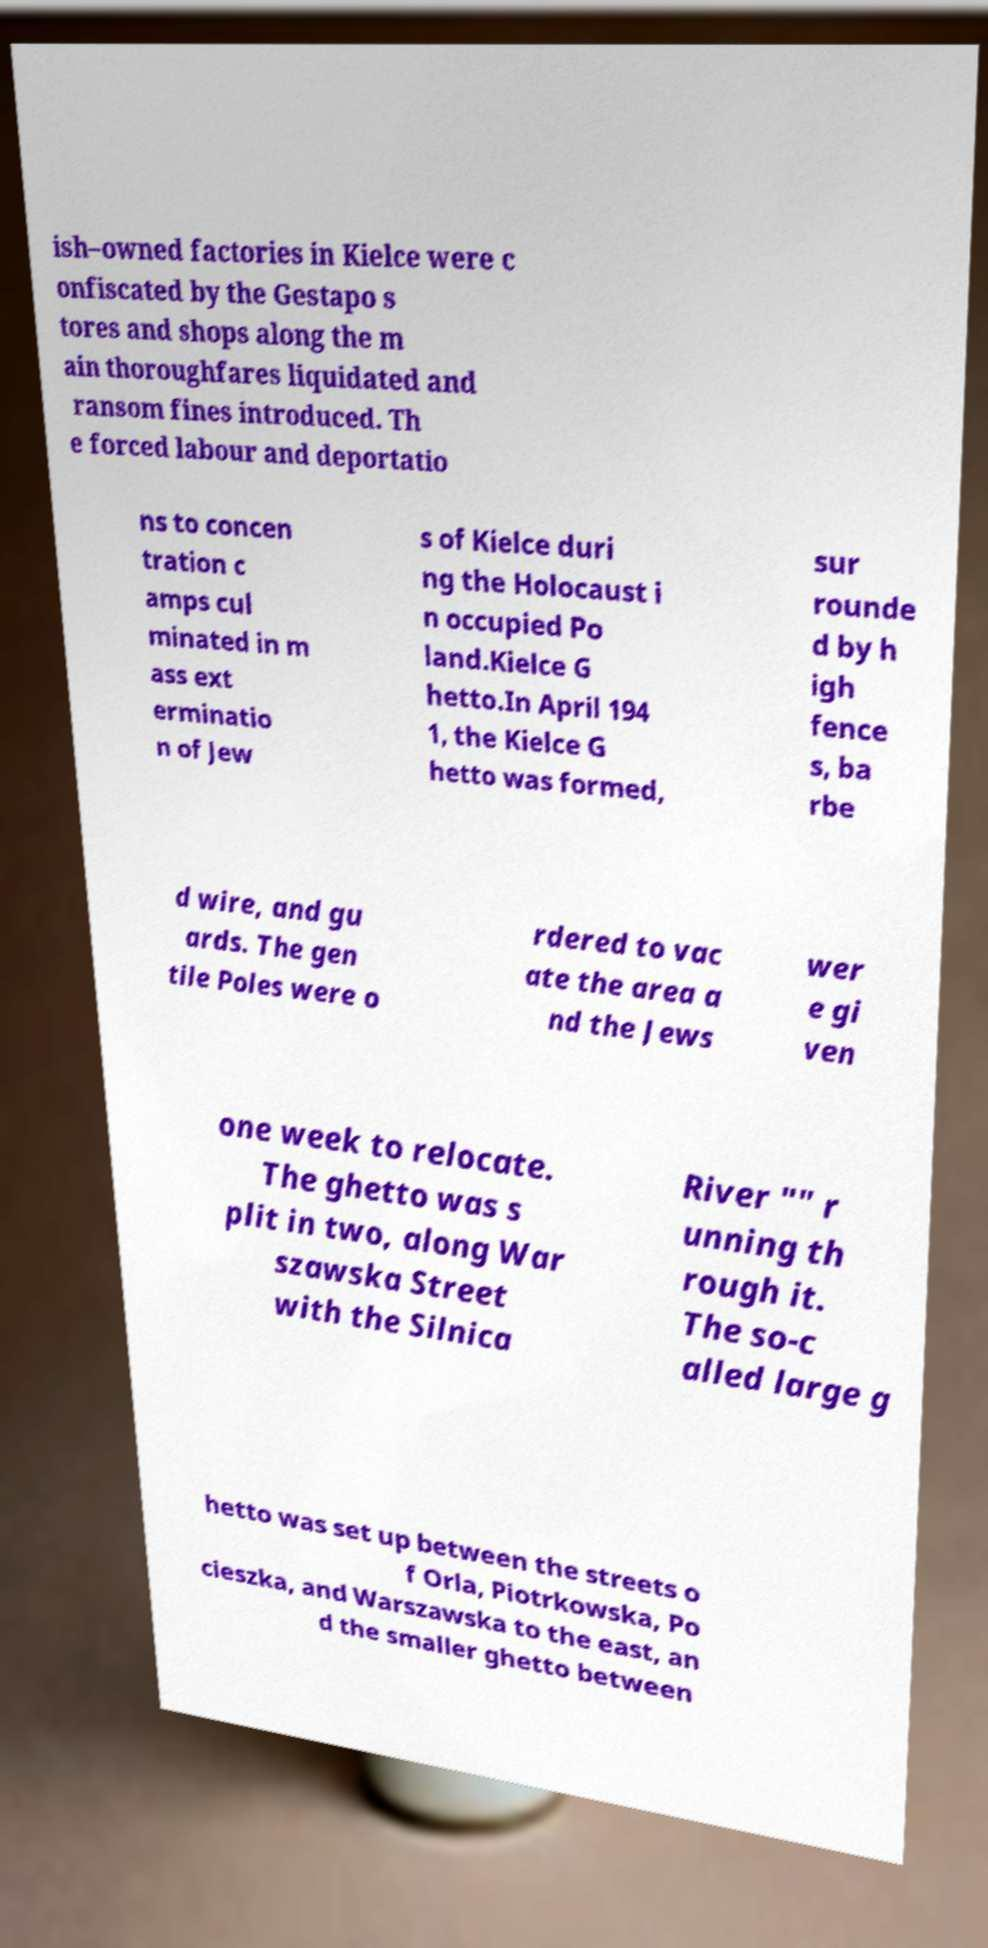I need the written content from this picture converted into text. Can you do that? ish–owned factories in Kielce were c onfiscated by the Gestapo s tores and shops along the m ain thoroughfares liquidated and ransom fines introduced. Th e forced labour and deportatio ns to concen tration c amps cul minated in m ass ext erminatio n of Jew s of Kielce duri ng the Holocaust i n occupied Po land.Kielce G hetto.In April 194 1, the Kielce G hetto was formed, sur rounde d by h igh fence s, ba rbe d wire, and gu ards. The gen tile Poles were o rdered to vac ate the area a nd the Jews wer e gi ven one week to relocate. The ghetto was s plit in two, along War szawska Street with the Silnica River "" r unning th rough it. The so-c alled large g hetto was set up between the streets o f Orla, Piotrkowska, Po cieszka, and Warszawska to the east, an d the smaller ghetto between 